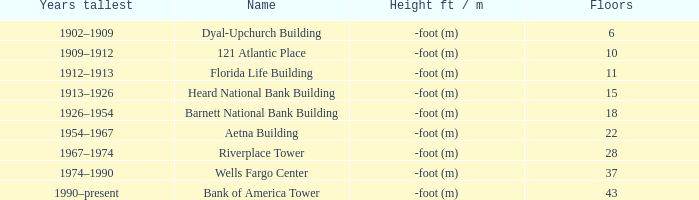What was the name of the building with 10 floors? 121 Atlantic Place. 